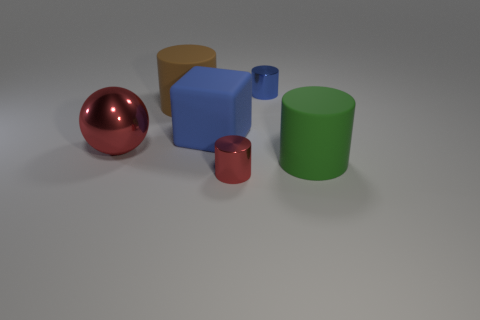Add 1 small brown metallic blocks. How many objects exist? 7 Subtract all cubes. How many objects are left? 5 Add 6 large red objects. How many large red objects are left? 7 Add 6 red metallic cylinders. How many red metallic cylinders exist? 7 Subtract 1 red cylinders. How many objects are left? 5 Subtract all matte cylinders. Subtract all green cylinders. How many objects are left? 3 